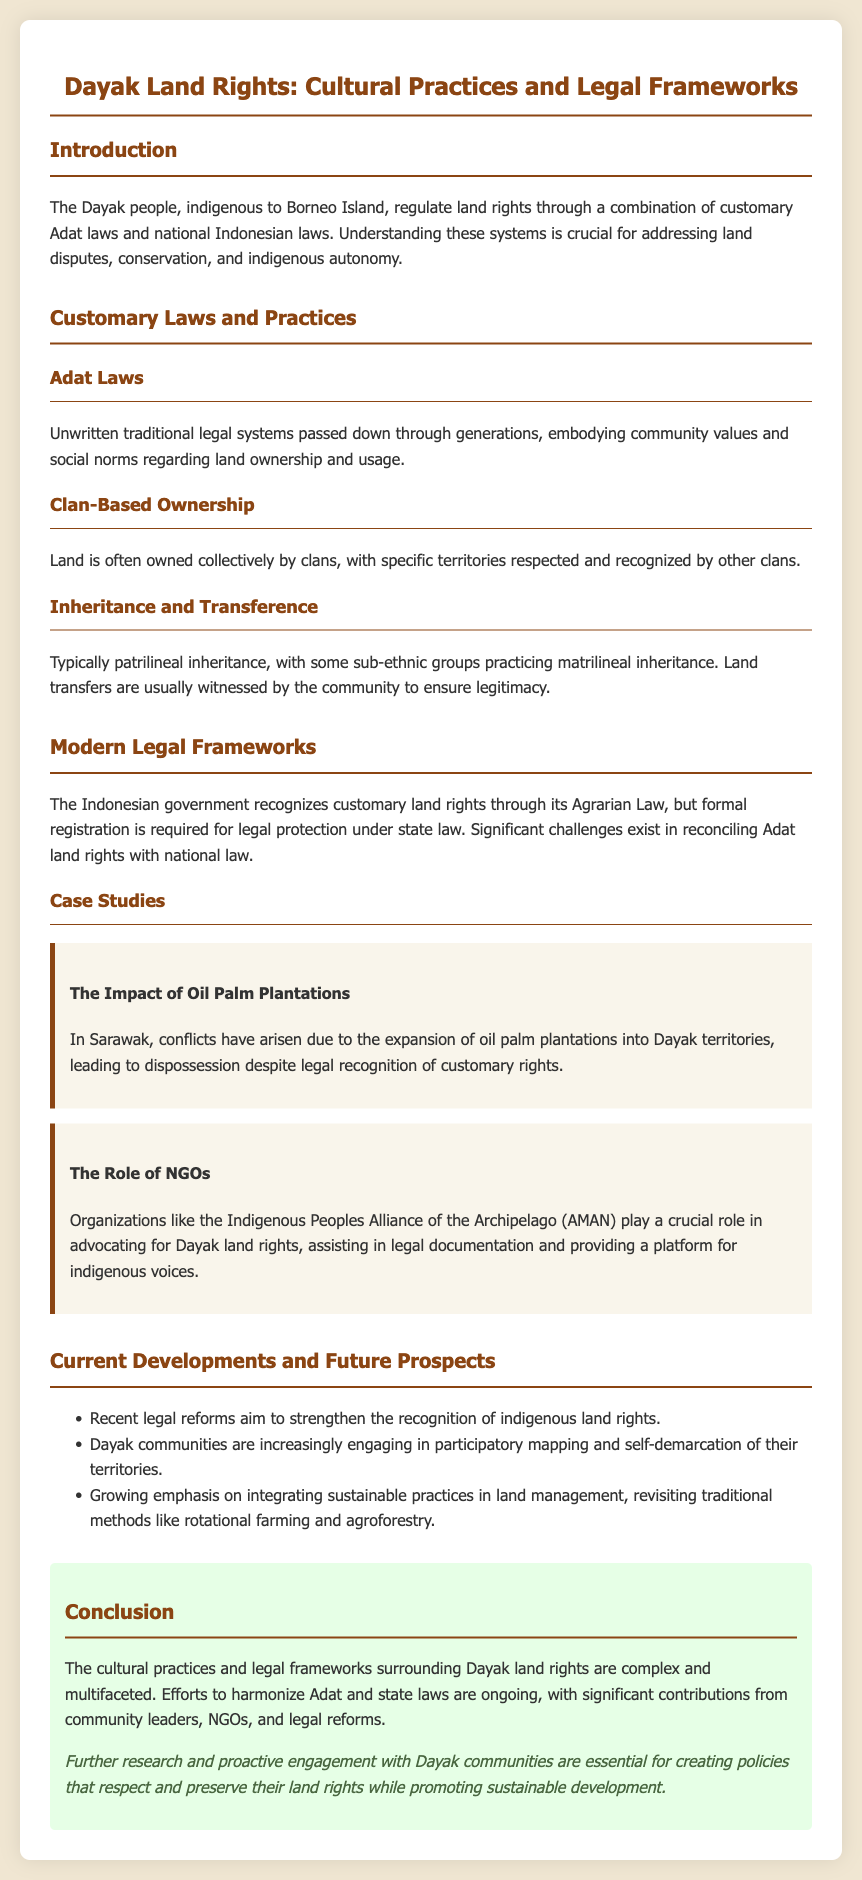What is the primary indigenous group discussed in the document? The document focuses on the Dayak people, who are indigenous to Borneo Island.
Answer: Dayak What legal system governs land rights among the Dayak? The Dayak govern land rights through a combination of customary Adat laws and national Indonesian laws.
Answer: Adat laws What form of land ownership is prevalent among the Dayak? Land is often owned collectively by clans, which is indicated as clan-based ownership in the document.
Answer: Clan-based ownership What is typically the basis for land inheritance in Dayak culture? The document states that inheritance is typically patrilineal, though some sub-ethnic groups practice matrilineal inheritance.
Answer: Patrilineal Which organization advocates for Dayak land rights? The Indigenous Peoples Alliance of the Archipelago (AMAN) is mentioned as a key advocate for Dayak land rights.
Answer: AMAN What major challenge do Dayak communities face with modern legal frameworks? The document highlights significant challenges in reconciling Adat land rights with national law.
Answer: Reconciling Adat land rights What recent trend is mentioned regarding Dayak land management practices? The document notes an increasing emphasis on integrating sustainable practices in land management.
Answer: Sustainable practices What impact do oil palm plantations have on Dayak territories? The document explains that conflicts have arisen due to the expansion of oil palm plantations into Dayak territories.
Answer: Dispossession What type of mapping are Dayak communities engaging in? The document states that Dayak communities are participating in participatory mapping of their territories.
Answer: Participatory mapping 